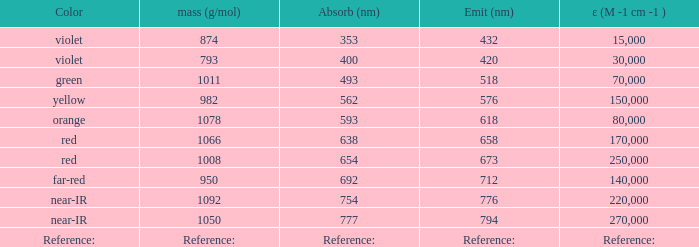What is the Absorbtion (in nanometers) of the color Orange? 593.0. 